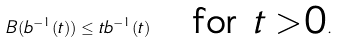<formula> <loc_0><loc_0><loc_500><loc_500>B ( b ^ { - 1 } ( t ) ) \leq t b ^ { - 1 } ( t ) \quad \text {for $t>0$} .</formula> 